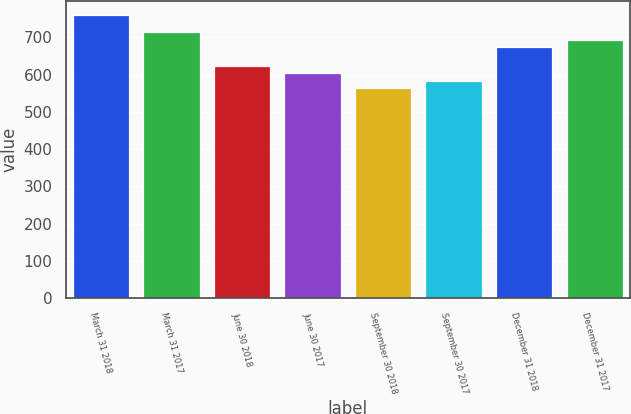<chart> <loc_0><loc_0><loc_500><loc_500><bar_chart><fcel>March 31 2018<fcel>March 31 2017<fcel>June 30 2018<fcel>June 30 2017<fcel>September 30 2018<fcel>September 30 2017<fcel>December 31 2018<fcel>December 31 2017<nl><fcel>760<fcel>713.2<fcel>622.8<fcel>603.2<fcel>564<fcel>583.6<fcel>674<fcel>693.6<nl></chart> 